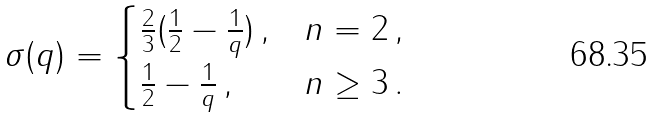<formula> <loc_0><loc_0><loc_500><loc_500>\sigma ( q ) = \begin{cases} \frac { 2 } { 3 } ( \frac { 1 } { 2 } - \frac { 1 } { q } ) \, , & n = 2 \, , \\ \frac { 1 } { 2 } - \frac { 1 } { q } \, , & n \geq 3 \, . \end{cases}</formula> 